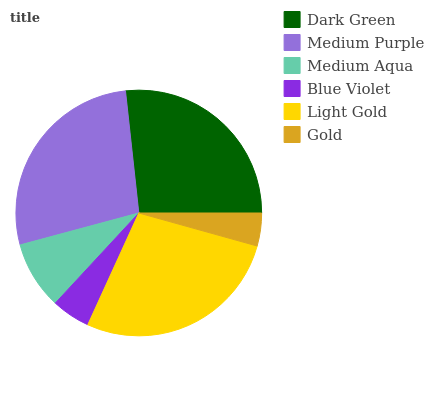Is Gold the minimum?
Answer yes or no. Yes. Is Light Gold the maximum?
Answer yes or no. Yes. Is Medium Purple the minimum?
Answer yes or no. No. Is Medium Purple the maximum?
Answer yes or no. No. Is Medium Purple greater than Dark Green?
Answer yes or no. Yes. Is Dark Green less than Medium Purple?
Answer yes or no. Yes. Is Dark Green greater than Medium Purple?
Answer yes or no. No. Is Medium Purple less than Dark Green?
Answer yes or no. No. Is Dark Green the high median?
Answer yes or no. Yes. Is Medium Aqua the low median?
Answer yes or no. Yes. Is Medium Purple the high median?
Answer yes or no. No. Is Blue Violet the low median?
Answer yes or no. No. 